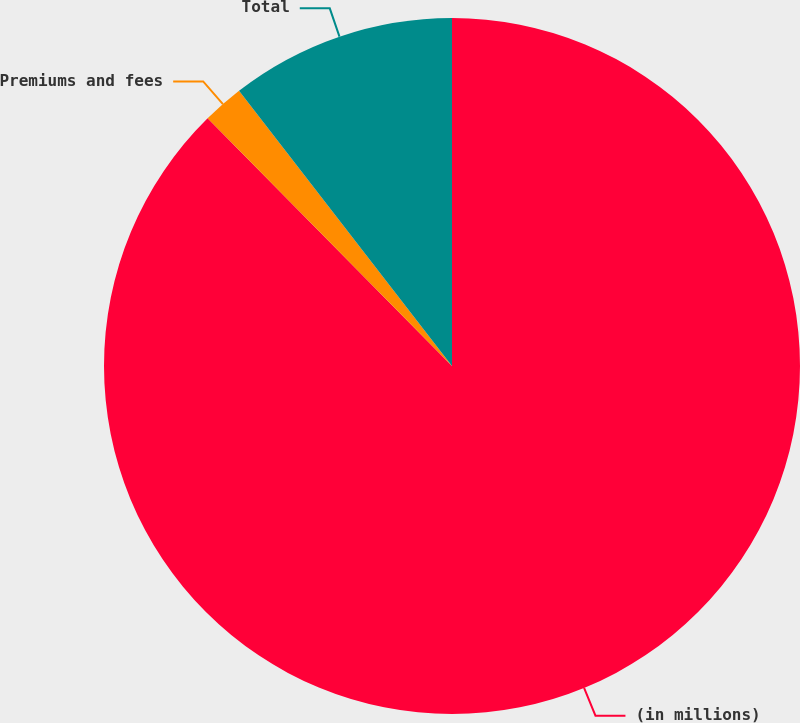Convert chart to OTSL. <chart><loc_0><loc_0><loc_500><loc_500><pie_chart><fcel>(in millions)<fcel>Premiums and fees<fcel>Total<nl><fcel>87.6%<fcel>1.91%<fcel>10.48%<nl></chart> 